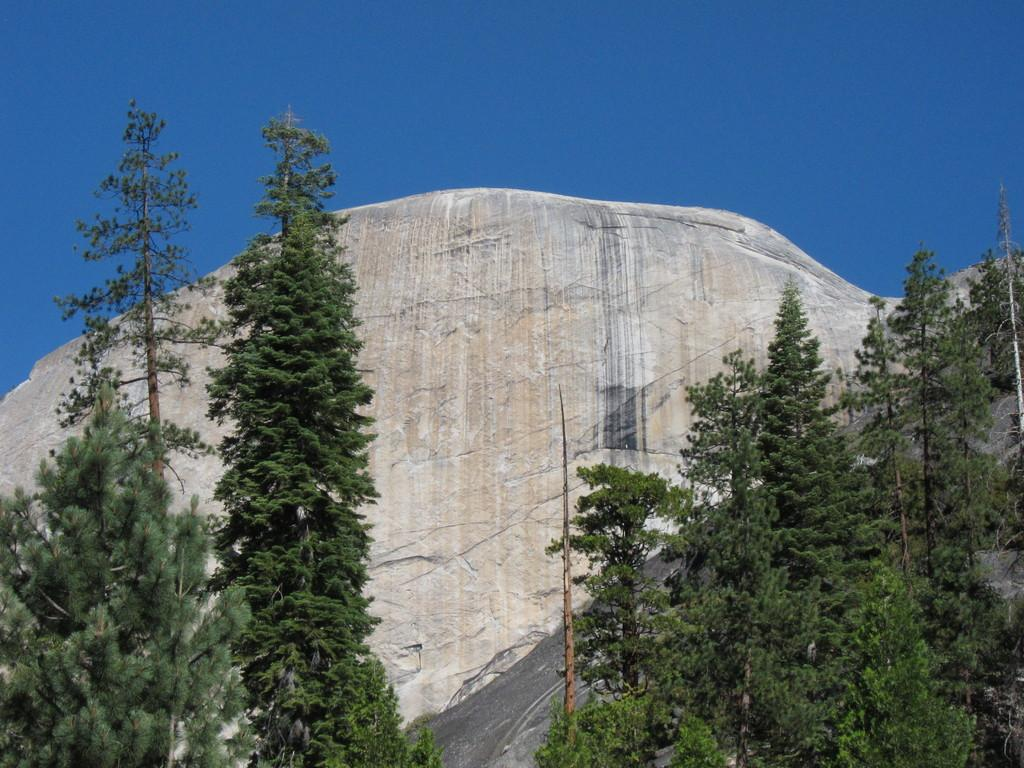What type of vegetation can be seen in the image? There are trees and plants in the image. Can you describe the landscape in the image? The image features a big rock or stone, along with the trees and plants. What color is the orange in the image? There is no orange present in the image. Is there any blood visible in the image? No, there is no blood visible in the image. Can you see any bombs in the image? No, there are no bombs present in the image. 